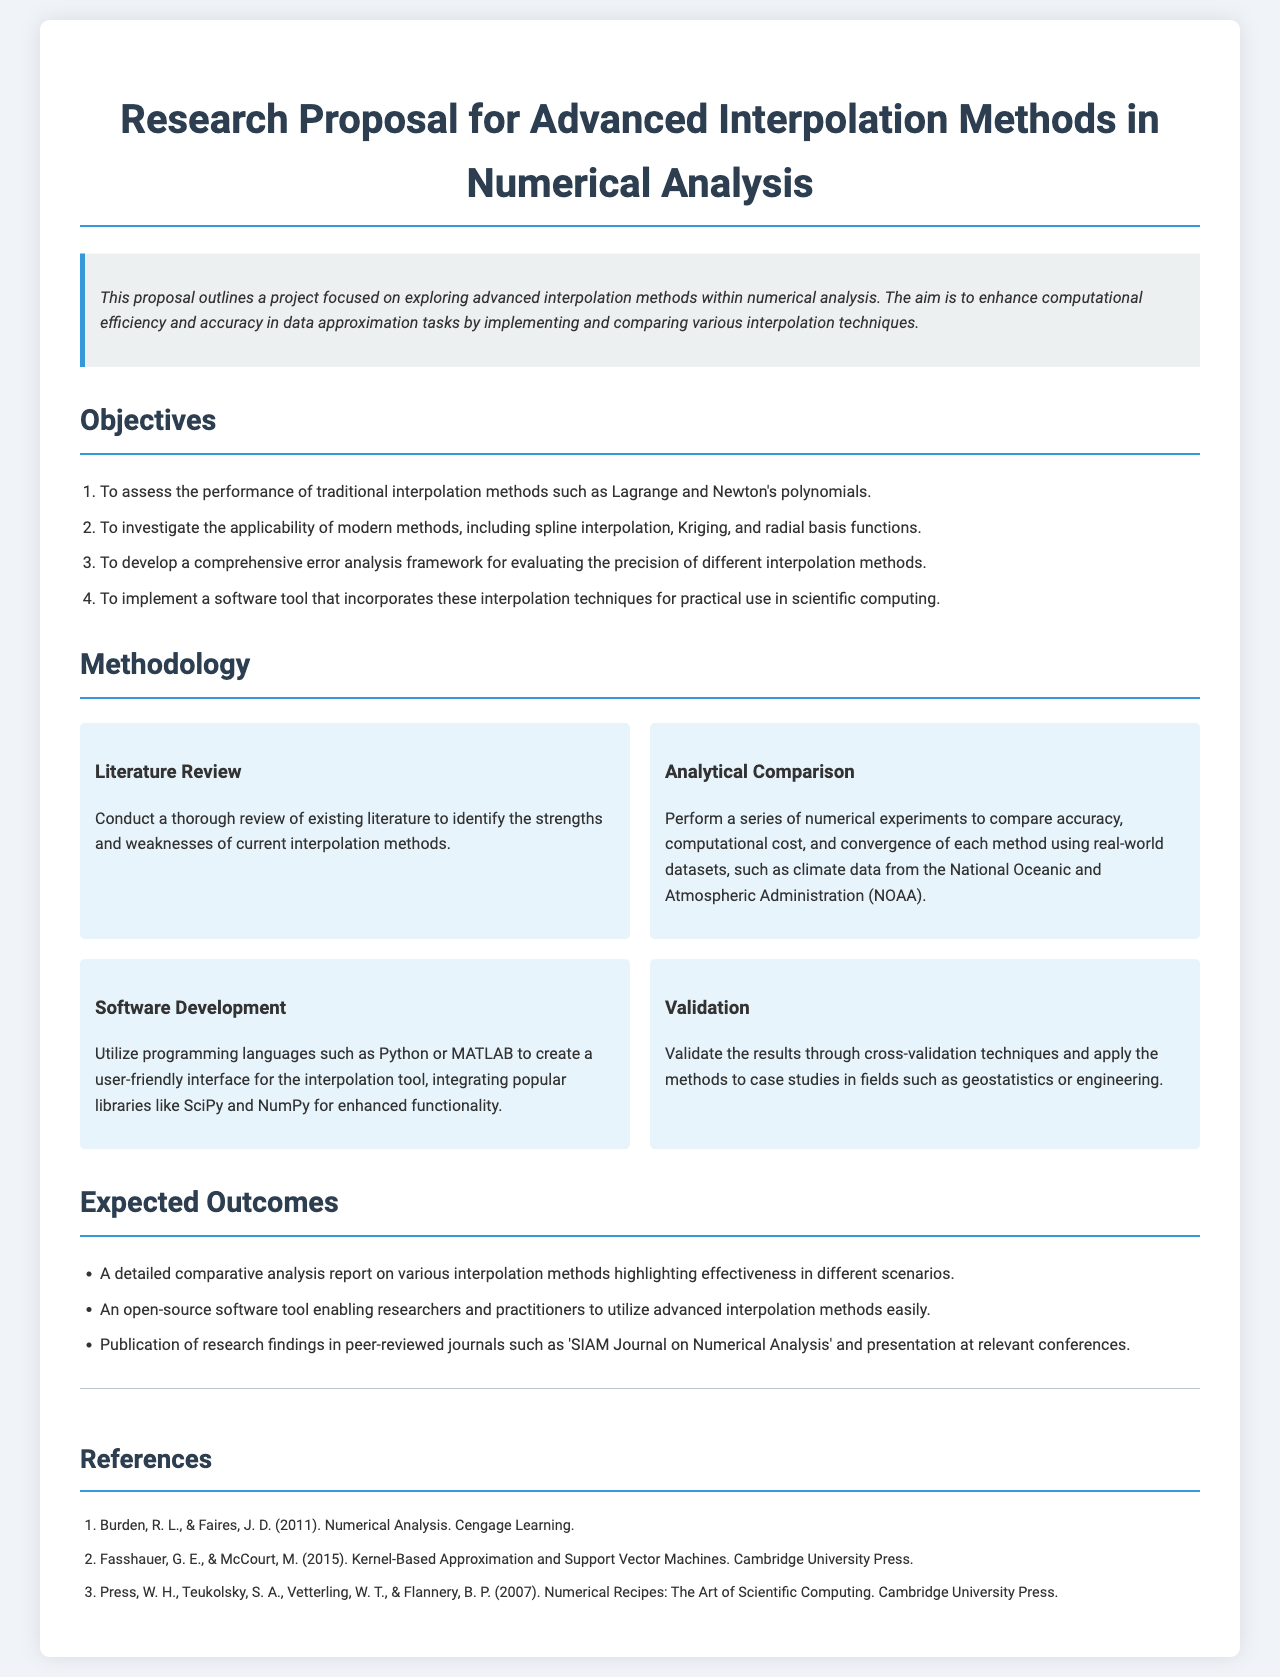What is the title of the proposal? The title of the proposal is stated prominently at the beginning of the document.
Answer: Research Proposal for Advanced Interpolation Methods in Numerical Analysis How many objectives are outlined in the proposal? The proposal lists a total of four specific objectives aimed at exploring interpolation methods.
Answer: 4 What programming languages are mentioned for software development? The document specifies the programming languages that will be used for developing the interpolation tool.
Answer: Python or MATLAB Which publication is mentioned for potential research findings? The proposal references a specific journal where the research findings may be published.
Answer: SIAM Journal on Numerical Analysis What type of analysis will be conducted on interpolation methods? The proposal indicates a specific analytical approach to assess various interpolation methods.
Answer: Comparative analysis What is one of the datasets mentioned for numerical experiments? The proposal includes a source for real-world datasets that will be used in the experiments.
Answer: NOAA What is the second methodology item described? The document lists multiple methodology items, and the second one is specified after the literature review.
Answer: Analytical Comparison Which method will be used for validating the results? The proposal includes a specific technique for ensuring the accuracy of the results obtained from the methods.
Answer: Cross-validation techniques 